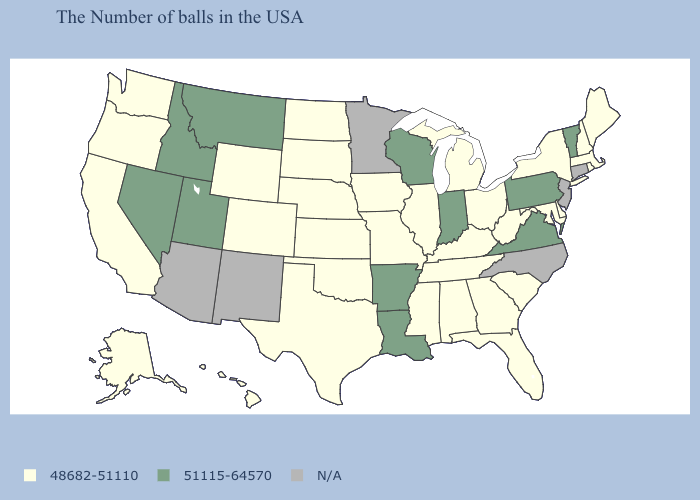What is the lowest value in the USA?
Give a very brief answer. 48682-51110. Which states hav the highest value in the South?
Be succinct. Virginia, Louisiana, Arkansas. Which states have the lowest value in the Northeast?
Quick response, please. Maine, Massachusetts, Rhode Island, New Hampshire, New York. How many symbols are there in the legend?
Give a very brief answer. 3. What is the value of Pennsylvania?
Write a very short answer. 51115-64570. Does Arkansas have the lowest value in the USA?
Write a very short answer. No. Name the states that have a value in the range 51115-64570?
Quick response, please. Vermont, Pennsylvania, Virginia, Indiana, Wisconsin, Louisiana, Arkansas, Utah, Montana, Idaho, Nevada. What is the value of Louisiana?
Keep it brief. 51115-64570. Name the states that have a value in the range 51115-64570?
Write a very short answer. Vermont, Pennsylvania, Virginia, Indiana, Wisconsin, Louisiana, Arkansas, Utah, Montana, Idaho, Nevada. Among the states that border Vermont , which have the lowest value?
Concise answer only. Massachusetts, New Hampshire, New York. Name the states that have a value in the range N/A?
Quick response, please. Connecticut, New Jersey, North Carolina, Minnesota, New Mexico, Arizona. Which states have the highest value in the USA?
Quick response, please. Vermont, Pennsylvania, Virginia, Indiana, Wisconsin, Louisiana, Arkansas, Utah, Montana, Idaho, Nevada. Does Utah have the lowest value in the West?
Give a very brief answer. No. What is the value of Utah?
Write a very short answer. 51115-64570. What is the value of Idaho?
Short answer required. 51115-64570. 